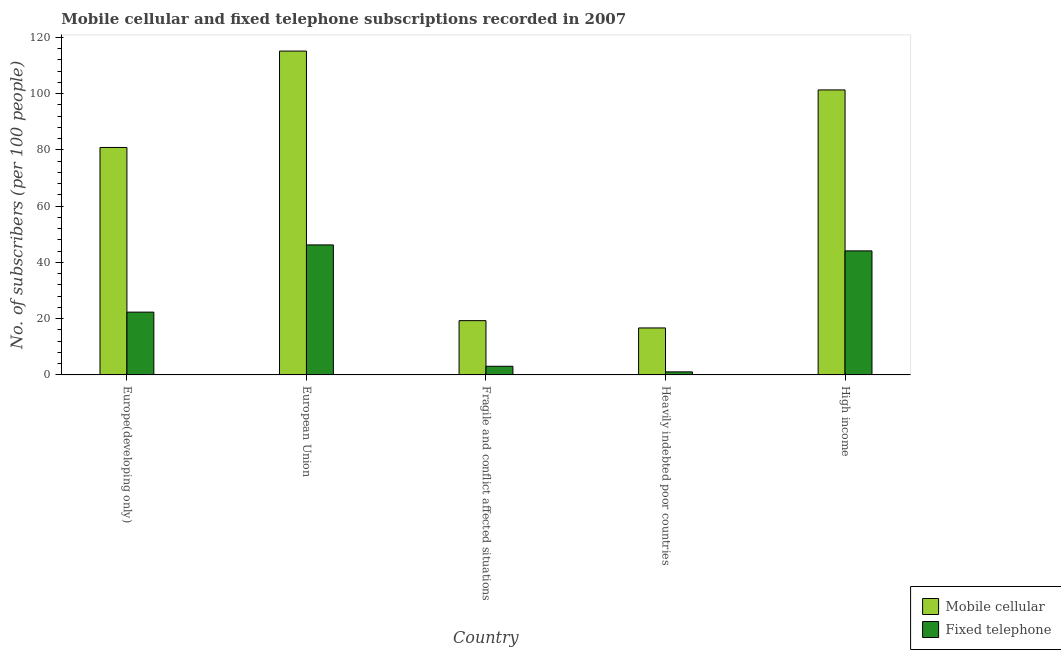How many different coloured bars are there?
Make the answer very short. 2. How many bars are there on the 3rd tick from the left?
Your response must be concise. 2. What is the label of the 1st group of bars from the left?
Ensure brevity in your answer.  Europe(developing only). In how many cases, is the number of bars for a given country not equal to the number of legend labels?
Your answer should be very brief. 0. What is the number of mobile cellular subscribers in High income?
Provide a short and direct response. 101.34. Across all countries, what is the maximum number of mobile cellular subscribers?
Offer a terse response. 115.16. Across all countries, what is the minimum number of fixed telephone subscribers?
Provide a succinct answer. 1.09. In which country was the number of mobile cellular subscribers maximum?
Your response must be concise. European Union. In which country was the number of fixed telephone subscribers minimum?
Your answer should be very brief. Heavily indebted poor countries. What is the total number of mobile cellular subscribers in the graph?
Offer a very short reply. 333.37. What is the difference between the number of mobile cellular subscribers in European Union and that in High income?
Offer a terse response. 13.82. What is the difference between the number of mobile cellular subscribers in Europe(developing only) and the number of fixed telephone subscribers in Fragile and conflict affected situations?
Keep it short and to the point. 77.81. What is the average number of mobile cellular subscribers per country?
Offer a terse response. 66.67. What is the difference between the number of fixed telephone subscribers and number of mobile cellular subscribers in European Union?
Offer a terse response. -68.93. In how many countries, is the number of mobile cellular subscribers greater than 84 ?
Your answer should be compact. 2. What is the ratio of the number of mobile cellular subscribers in Europe(developing only) to that in High income?
Provide a succinct answer. 0.8. Is the difference between the number of mobile cellular subscribers in European Union and High income greater than the difference between the number of fixed telephone subscribers in European Union and High income?
Provide a short and direct response. Yes. What is the difference between the highest and the second highest number of fixed telephone subscribers?
Make the answer very short. 2.12. What is the difference between the highest and the lowest number of fixed telephone subscribers?
Your answer should be very brief. 45.14. What does the 1st bar from the left in Heavily indebted poor countries represents?
Make the answer very short. Mobile cellular. What does the 1st bar from the right in Heavily indebted poor countries represents?
Provide a short and direct response. Fixed telephone. How many bars are there?
Ensure brevity in your answer.  10. What is the difference between two consecutive major ticks on the Y-axis?
Provide a succinct answer. 20. Are the values on the major ticks of Y-axis written in scientific E-notation?
Keep it short and to the point. No. Does the graph contain grids?
Ensure brevity in your answer.  No. Where does the legend appear in the graph?
Your response must be concise. Bottom right. What is the title of the graph?
Give a very brief answer. Mobile cellular and fixed telephone subscriptions recorded in 2007. Does "Birth rate" appear as one of the legend labels in the graph?
Your answer should be compact. No. What is the label or title of the Y-axis?
Provide a short and direct response. No. of subscribers (per 100 people). What is the No. of subscribers (per 100 people) in Mobile cellular in Europe(developing only)?
Offer a terse response. 80.88. What is the No. of subscribers (per 100 people) in Fixed telephone in Europe(developing only)?
Keep it short and to the point. 22.32. What is the No. of subscribers (per 100 people) in Mobile cellular in European Union?
Keep it short and to the point. 115.16. What is the No. of subscribers (per 100 people) in Fixed telephone in European Union?
Offer a very short reply. 46.22. What is the No. of subscribers (per 100 people) of Mobile cellular in Fragile and conflict affected situations?
Offer a terse response. 19.29. What is the No. of subscribers (per 100 people) in Fixed telephone in Fragile and conflict affected situations?
Make the answer very short. 3.07. What is the No. of subscribers (per 100 people) in Mobile cellular in Heavily indebted poor countries?
Your answer should be very brief. 16.7. What is the No. of subscribers (per 100 people) in Fixed telephone in Heavily indebted poor countries?
Your answer should be very brief. 1.09. What is the No. of subscribers (per 100 people) of Mobile cellular in High income?
Offer a very short reply. 101.34. What is the No. of subscribers (per 100 people) of Fixed telephone in High income?
Ensure brevity in your answer.  44.1. Across all countries, what is the maximum No. of subscribers (per 100 people) in Mobile cellular?
Keep it short and to the point. 115.16. Across all countries, what is the maximum No. of subscribers (per 100 people) of Fixed telephone?
Offer a terse response. 46.22. Across all countries, what is the minimum No. of subscribers (per 100 people) in Mobile cellular?
Offer a terse response. 16.7. Across all countries, what is the minimum No. of subscribers (per 100 people) in Fixed telephone?
Give a very brief answer. 1.09. What is the total No. of subscribers (per 100 people) in Mobile cellular in the graph?
Offer a terse response. 333.37. What is the total No. of subscribers (per 100 people) of Fixed telephone in the graph?
Give a very brief answer. 116.8. What is the difference between the No. of subscribers (per 100 people) of Mobile cellular in Europe(developing only) and that in European Union?
Provide a succinct answer. -34.27. What is the difference between the No. of subscribers (per 100 people) of Fixed telephone in Europe(developing only) and that in European Union?
Ensure brevity in your answer.  -23.9. What is the difference between the No. of subscribers (per 100 people) in Mobile cellular in Europe(developing only) and that in Fragile and conflict affected situations?
Your response must be concise. 61.59. What is the difference between the No. of subscribers (per 100 people) in Fixed telephone in Europe(developing only) and that in Fragile and conflict affected situations?
Offer a very short reply. 19.26. What is the difference between the No. of subscribers (per 100 people) of Mobile cellular in Europe(developing only) and that in Heavily indebted poor countries?
Make the answer very short. 64.18. What is the difference between the No. of subscribers (per 100 people) in Fixed telephone in Europe(developing only) and that in Heavily indebted poor countries?
Your answer should be very brief. 21.24. What is the difference between the No. of subscribers (per 100 people) of Mobile cellular in Europe(developing only) and that in High income?
Offer a very short reply. -20.46. What is the difference between the No. of subscribers (per 100 people) of Fixed telephone in Europe(developing only) and that in High income?
Keep it short and to the point. -21.78. What is the difference between the No. of subscribers (per 100 people) of Mobile cellular in European Union and that in Fragile and conflict affected situations?
Provide a short and direct response. 95.86. What is the difference between the No. of subscribers (per 100 people) in Fixed telephone in European Union and that in Fragile and conflict affected situations?
Keep it short and to the point. 43.16. What is the difference between the No. of subscribers (per 100 people) in Mobile cellular in European Union and that in Heavily indebted poor countries?
Offer a very short reply. 98.46. What is the difference between the No. of subscribers (per 100 people) of Fixed telephone in European Union and that in Heavily indebted poor countries?
Make the answer very short. 45.14. What is the difference between the No. of subscribers (per 100 people) of Mobile cellular in European Union and that in High income?
Make the answer very short. 13.82. What is the difference between the No. of subscribers (per 100 people) in Fixed telephone in European Union and that in High income?
Offer a terse response. 2.12. What is the difference between the No. of subscribers (per 100 people) of Mobile cellular in Fragile and conflict affected situations and that in Heavily indebted poor countries?
Your response must be concise. 2.59. What is the difference between the No. of subscribers (per 100 people) of Fixed telephone in Fragile and conflict affected situations and that in Heavily indebted poor countries?
Your answer should be very brief. 1.98. What is the difference between the No. of subscribers (per 100 people) of Mobile cellular in Fragile and conflict affected situations and that in High income?
Your answer should be compact. -82.05. What is the difference between the No. of subscribers (per 100 people) in Fixed telephone in Fragile and conflict affected situations and that in High income?
Provide a short and direct response. -41.03. What is the difference between the No. of subscribers (per 100 people) in Mobile cellular in Heavily indebted poor countries and that in High income?
Your response must be concise. -84.64. What is the difference between the No. of subscribers (per 100 people) in Fixed telephone in Heavily indebted poor countries and that in High income?
Offer a very short reply. -43.02. What is the difference between the No. of subscribers (per 100 people) of Mobile cellular in Europe(developing only) and the No. of subscribers (per 100 people) of Fixed telephone in European Union?
Give a very brief answer. 34.66. What is the difference between the No. of subscribers (per 100 people) of Mobile cellular in Europe(developing only) and the No. of subscribers (per 100 people) of Fixed telephone in Fragile and conflict affected situations?
Your answer should be compact. 77.81. What is the difference between the No. of subscribers (per 100 people) of Mobile cellular in Europe(developing only) and the No. of subscribers (per 100 people) of Fixed telephone in Heavily indebted poor countries?
Your answer should be compact. 79.8. What is the difference between the No. of subscribers (per 100 people) in Mobile cellular in Europe(developing only) and the No. of subscribers (per 100 people) in Fixed telephone in High income?
Your answer should be very brief. 36.78. What is the difference between the No. of subscribers (per 100 people) of Mobile cellular in European Union and the No. of subscribers (per 100 people) of Fixed telephone in Fragile and conflict affected situations?
Your answer should be very brief. 112.09. What is the difference between the No. of subscribers (per 100 people) of Mobile cellular in European Union and the No. of subscribers (per 100 people) of Fixed telephone in Heavily indebted poor countries?
Your response must be concise. 114.07. What is the difference between the No. of subscribers (per 100 people) in Mobile cellular in European Union and the No. of subscribers (per 100 people) in Fixed telephone in High income?
Your answer should be compact. 71.06. What is the difference between the No. of subscribers (per 100 people) in Mobile cellular in Fragile and conflict affected situations and the No. of subscribers (per 100 people) in Fixed telephone in Heavily indebted poor countries?
Offer a terse response. 18.21. What is the difference between the No. of subscribers (per 100 people) of Mobile cellular in Fragile and conflict affected situations and the No. of subscribers (per 100 people) of Fixed telephone in High income?
Offer a very short reply. -24.81. What is the difference between the No. of subscribers (per 100 people) in Mobile cellular in Heavily indebted poor countries and the No. of subscribers (per 100 people) in Fixed telephone in High income?
Your answer should be very brief. -27.4. What is the average No. of subscribers (per 100 people) in Mobile cellular per country?
Your response must be concise. 66.67. What is the average No. of subscribers (per 100 people) in Fixed telephone per country?
Keep it short and to the point. 23.36. What is the difference between the No. of subscribers (per 100 people) of Mobile cellular and No. of subscribers (per 100 people) of Fixed telephone in Europe(developing only)?
Ensure brevity in your answer.  58.56. What is the difference between the No. of subscribers (per 100 people) in Mobile cellular and No. of subscribers (per 100 people) in Fixed telephone in European Union?
Offer a very short reply. 68.93. What is the difference between the No. of subscribers (per 100 people) in Mobile cellular and No. of subscribers (per 100 people) in Fixed telephone in Fragile and conflict affected situations?
Your answer should be compact. 16.22. What is the difference between the No. of subscribers (per 100 people) in Mobile cellular and No. of subscribers (per 100 people) in Fixed telephone in Heavily indebted poor countries?
Provide a succinct answer. 15.61. What is the difference between the No. of subscribers (per 100 people) in Mobile cellular and No. of subscribers (per 100 people) in Fixed telephone in High income?
Keep it short and to the point. 57.24. What is the ratio of the No. of subscribers (per 100 people) in Mobile cellular in Europe(developing only) to that in European Union?
Ensure brevity in your answer.  0.7. What is the ratio of the No. of subscribers (per 100 people) of Fixed telephone in Europe(developing only) to that in European Union?
Your answer should be very brief. 0.48. What is the ratio of the No. of subscribers (per 100 people) in Mobile cellular in Europe(developing only) to that in Fragile and conflict affected situations?
Your answer should be compact. 4.19. What is the ratio of the No. of subscribers (per 100 people) in Fixed telephone in Europe(developing only) to that in Fragile and conflict affected situations?
Your response must be concise. 7.27. What is the ratio of the No. of subscribers (per 100 people) in Mobile cellular in Europe(developing only) to that in Heavily indebted poor countries?
Offer a terse response. 4.84. What is the ratio of the No. of subscribers (per 100 people) in Fixed telephone in Europe(developing only) to that in Heavily indebted poor countries?
Provide a succinct answer. 20.58. What is the ratio of the No. of subscribers (per 100 people) of Mobile cellular in Europe(developing only) to that in High income?
Your response must be concise. 0.8. What is the ratio of the No. of subscribers (per 100 people) in Fixed telephone in Europe(developing only) to that in High income?
Provide a short and direct response. 0.51. What is the ratio of the No. of subscribers (per 100 people) in Mobile cellular in European Union to that in Fragile and conflict affected situations?
Ensure brevity in your answer.  5.97. What is the ratio of the No. of subscribers (per 100 people) in Fixed telephone in European Union to that in Fragile and conflict affected situations?
Make the answer very short. 15.06. What is the ratio of the No. of subscribers (per 100 people) in Mobile cellular in European Union to that in Heavily indebted poor countries?
Your answer should be compact. 6.9. What is the ratio of the No. of subscribers (per 100 people) of Fixed telephone in European Union to that in Heavily indebted poor countries?
Make the answer very short. 42.6. What is the ratio of the No. of subscribers (per 100 people) in Mobile cellular in European Union to that in High income?
Your answer should be very brief. 1.14. What is the ratio of the No. of subscribers (per 100 people) in Fixed telephone in European Union to that in High income?
Offer a terse response. 1.05. What is the ratio of the No. of subscribers (per 100 people) of Mobile cellular in Fragile and conflict affected situations to that in Heavily indebted poor countries?
Offer a terse response. 1.16. What is the ratio of the No. of subscribers (per 100 people) in Fixed telephone in Fragile and conflict affected situations to that in Heavily indebted poor countries?
Keep it short and to the point. 2.83. What is the ratio of the No. of subscribers (per 100 people) of Mobile cellular in Fragile and conflict affected situations to that in High income?
Your answer should be very brief. 0.19. What is the ratio of the No. of subscribers (per 100 people) of Fixed telephone in Fragile and conflict affected situations to that in High income?
Give a very brief answer. 0.07. What is the ratio of the No. of subscribers (per 100 people) of Mobile cellular in Heavily indebted poor countries to that in High income?
Give a very brief answer. 0.16. What is the ratio of the No. of subscribers (per 100 people) of Fixed telephone in Heavily indebted poor countries to that in High income?
Keep it short and to the point. 0.02. What is the difference between the highest and the second highest No. of subscribers (per 100 people) in Mobile cellular?
Your answer should be very brief. 13.82. What is the difference between the highest and the second highest No. of subscribers (per 100 people) of Fixed telephone?
Offer a very short reply. 2.12. What is the difference between the highest and the lowest No. of subscribers (per 100 people) of Mobile cellular?
Ensure brevity in your answer.  98.46. What is the difference between the highest and the lowest No. of subscribers (per 100 people) in Fixed telephone?
Offer a terse response. 45.14. 